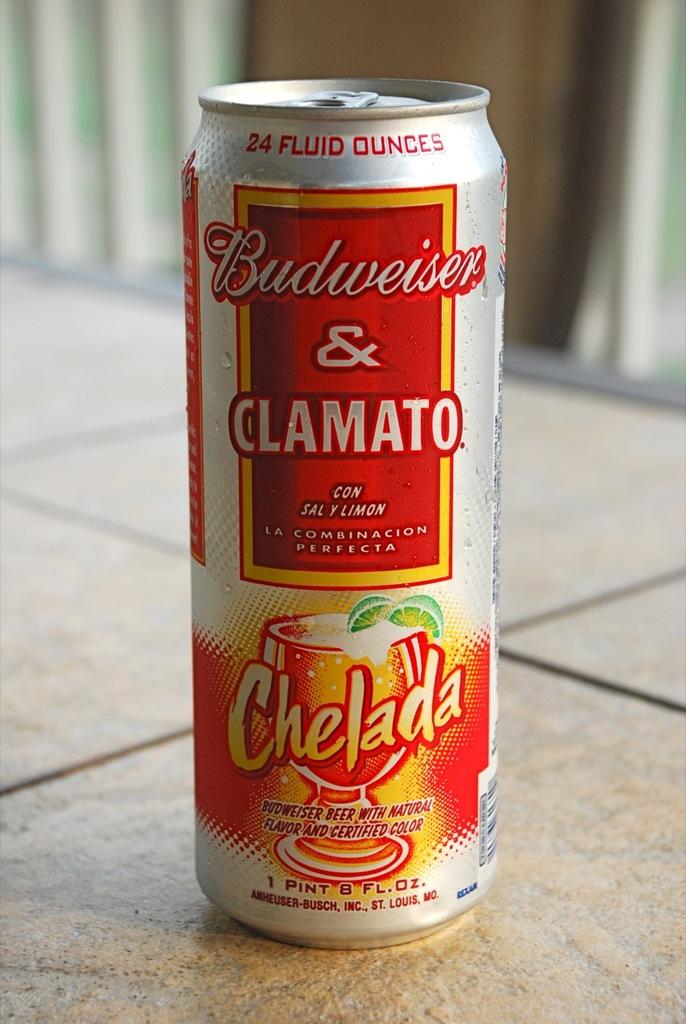What is mixed with the budweiser?
Give a very brief answer. Clamato. What brand of beer in on this can?
Keep it short and to the point. Budweiser. 